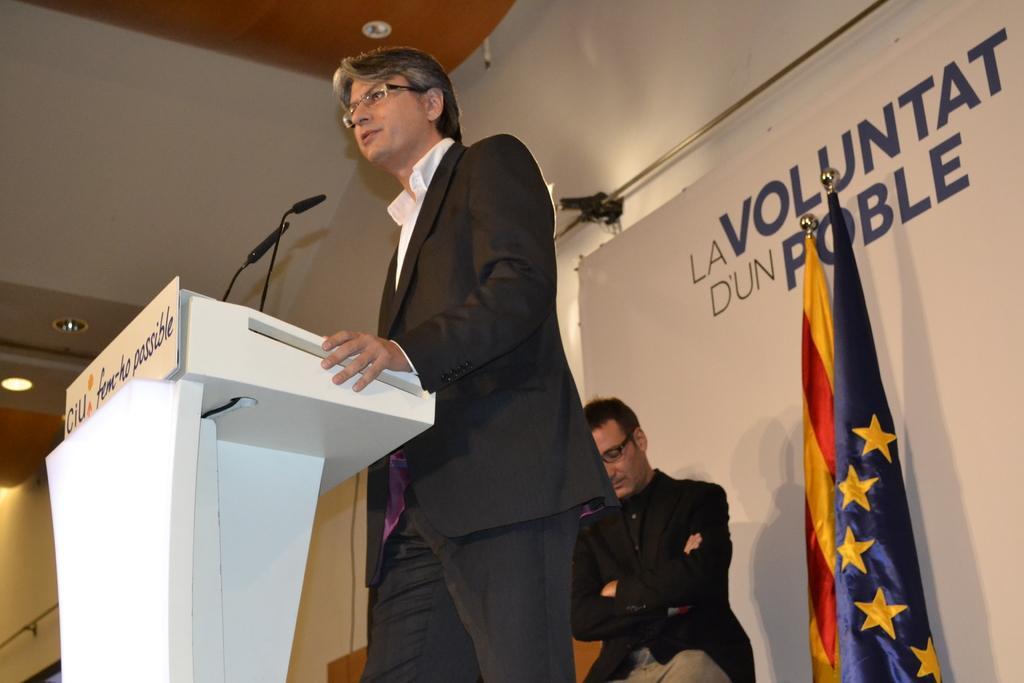Please provide a concise description of this image. In this picture I can observe a person standing in front of a podium. There are two mics on the podium. This person is wearing black color coat. Behind him there are two flags on the right side. There is another person sitting on the stage. In the background I can observe a poster. There is some text on the poster. 